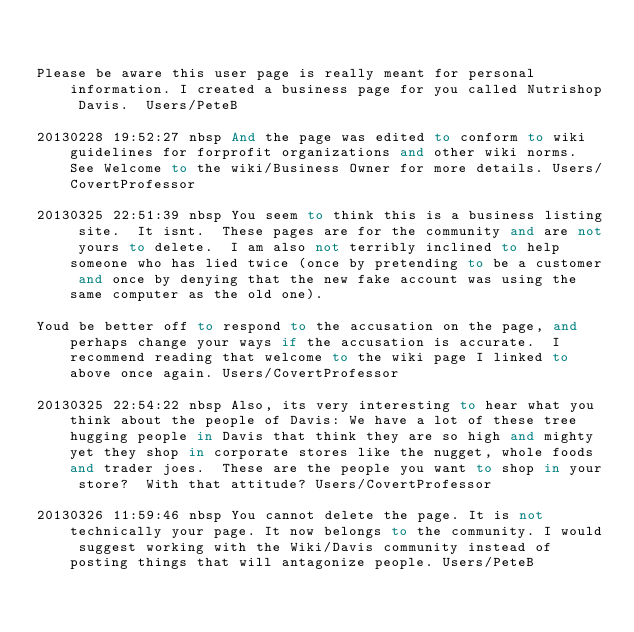Convert code to text. <code><loc_0><loc_0><loc_500><loc_500><_FORTRAN_>

Please be aware this user page is really meant for personal information. I created a business page for you called Nutrishop Davis.  Users/PeteB

20130228 19:52:27 nbsp And the page was edited to conform to wiki guidelines for forprofit organizations and other wiki norms.  See Welcome to the wiki/Business Owner for more details. Users/CovertProfessor

20130325 22:51:39 nbsp You seem to think this is a business listing site.  It isnt.  These pages are for the community and are not yours to delete.  I am also not terribly inclined to help someone who has lied twice (once by pretending to be a customer and once by denying that the new fake account was using the same computer as the old one).

Youd be better off to respond to the accusation on the page, and perhaps change your ways if the accusation is accurate.  I recommend reading that welcome to the wiki page I linked to above once again. Users/CovertProfessor

20130325 22:54:22 nbsp Also, its very interesting to hear what you think about the people of Davis: We have a lot of these tree hugging people in Davis that think they are so high and mighty yet they shop in corporate stores like the nugget, whole foods and trader joes.  These are the people you want to shop in your store?  With that attitude? Users/CovertProfessor

20130326 11:59:46 nbsp You cannot delete the page. It is not technically your page. It now belongs to the community. I would suggest working with the Wiki/Davis community instead of posting things that will antagonize people. Users/PeteB
</code> 